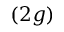Convert formula to latex. <formula><loc_0><loc_0><loc_500><loc_500>( 2 g )</formula> 